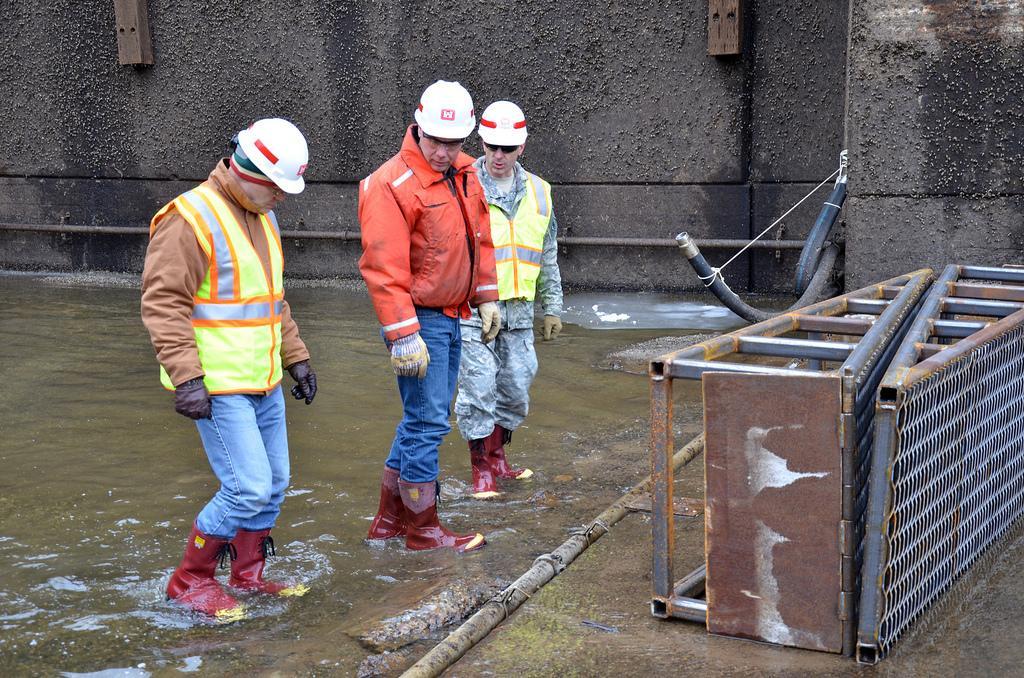Can you describe this image briefly? This picture describes about group of people, they are standing in the water, and they wore helmets, in front of them we can see few metal rods and pipes. 